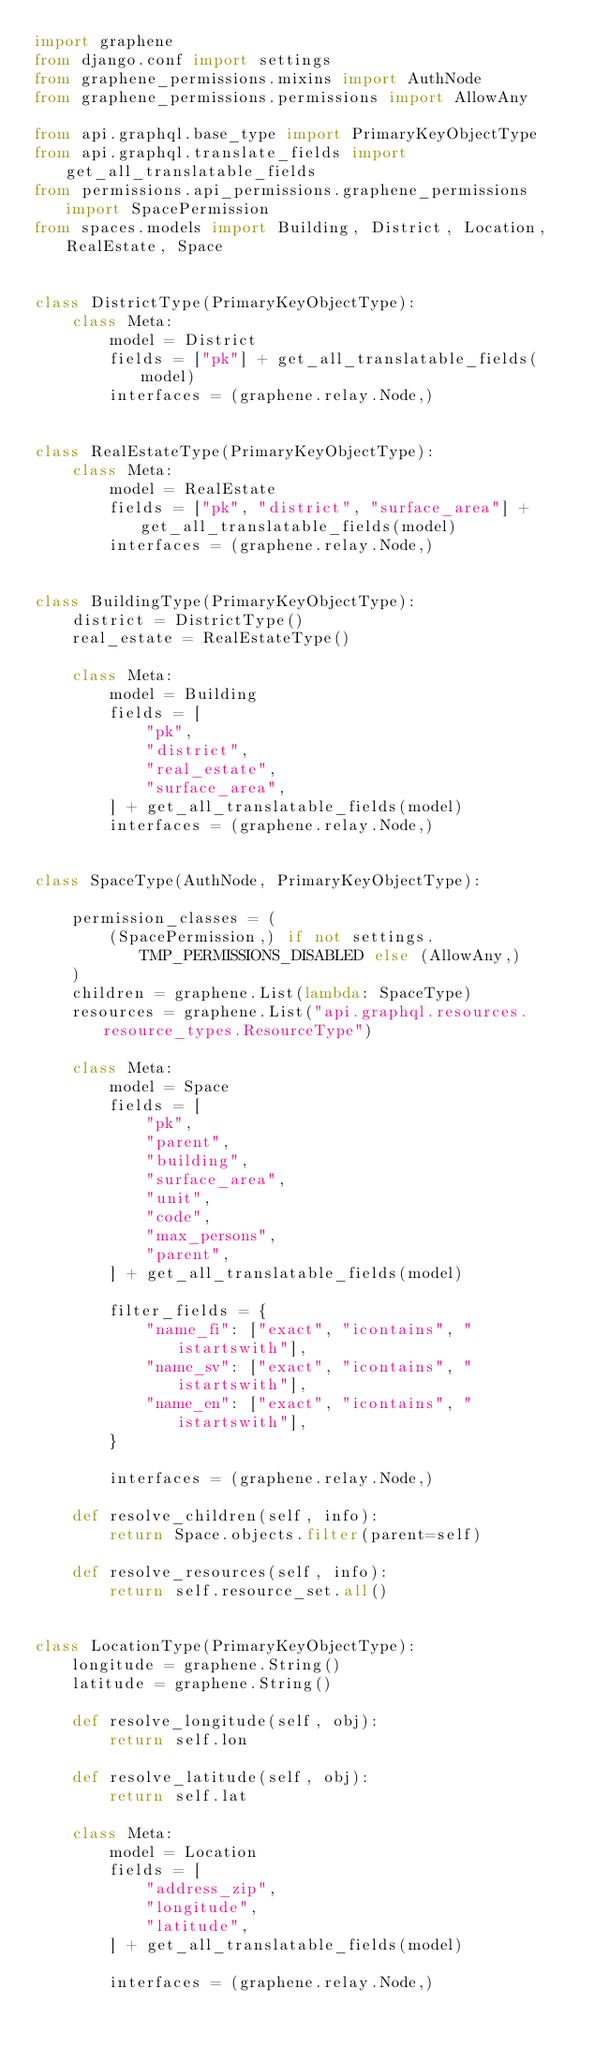Convert code to text. <code><loc_0><loc_0><loc_500><loc_500><_Python_>import graphene
from django.conf import settings
from graphene_permissions.mixins import AuthNode
from graphene_permissions.permissions import AllowAny

from api.graphql.base_type import PrimaryKeyObjectType
from api.graphql.translate_fields import get_all_translatable_fields
from permissions.api_permissions.graphene_permissions import SpacePermission
from spaces.models import Building, District, Location, RealEstate, Space


class DistrictType(PrimaryKeyObjectType):
    class Meta:
        model = District
        fields = ["pk"] + get_all_translatable_fields(model)
        interfaces = (graphene.relay.Node,)


class RealEstateType(PrimaryKeyObjectType):
    class Meta:
        model = RealEstate
        fields = ["pk", "district", "surface_area"] + get_all_translatable_fields(model)
        interfaces = (graphene.relay.Node,)


class BuildingType(PrimaryKeyObjectType):
    district = DistrictType()
    real_estate = RealEstateType()

    class Meta:
        model = Building
        fields = [
            "pk",
            "district",
            "real_estate",
            "surface_area",
        ] + get_all_translatable_fields(model)
        interfaces = (graphene.relay.Node,)


class SpaceType(AuthNode, PrimaryKeyObjectType):

    permission_classes = (
        (SpacePermission,) if not settings.TMP_PERMISSIONS_DISABLED else (AllowAny,)
    )
    children = graphene.List(lambda: SpaceType)
    resources = graphene.List("api.graphql.resources.resource_types.ResourceType")

    class Meta:
        model = Space
        fields = [
            "pk",
            "parent",
            "building",
            "surface_area",
            "unit",
            "code",
            "max_persons",
            "parent",
        ] + get_all_translatable_fields(model)

        filter_fields = {
            "name_fi": ["exact", "icontains", "istartswith"],
            "name_sv": ["exact", "icontains", "istartswith"],
            "name_en": ["exact", "icontains", "istartswith"],
        }

        interfaces = (graphene.relay.Node,)

    def resolve_children(self, info):
        return Space.objects.filter(parent=self)

    def resolve_resources(self, info):
        return self.resource_set.all()


class LocationType(PrimaryKeyObjectType):
    longitude = graphene.String()
    latitude = graphene.String()

    def resolve_longitude(self, obj):
        return self.lon

    def resolve_latitude(self, obj):
        return self.lat

    class Meta:
        model = Location
        fields = [
            "address_zip",
            "longitude",
            "latitude",
        ] + get_all_translatable_fields(model)

        interfaces = (graphene.relay.Node,)
</code> 